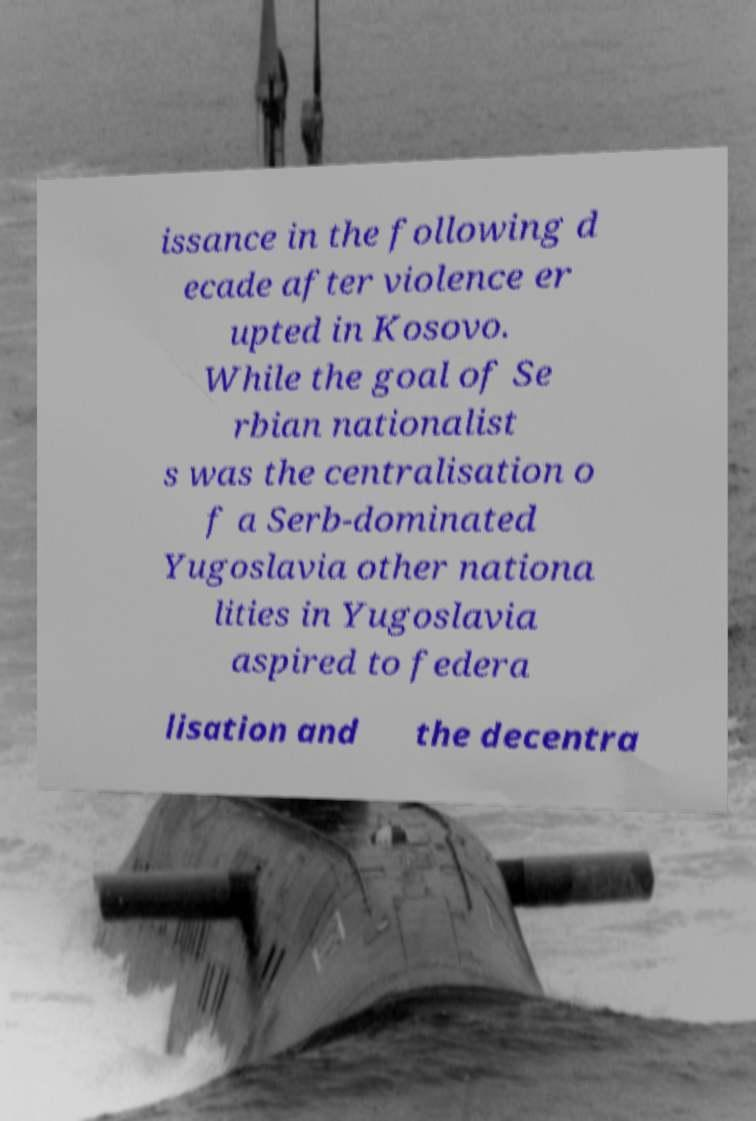There's text embedded in this image that I need extracted. Can you transcribe it verbatim? issance in the following d ecade after violence er upted in Kosovo. While the goal of Se rbian nationalist s was the centralisation o f a Serb-dominated Yugoslavia other nationa lities in Yugoslavia aspired to federa lisation and the decentra 